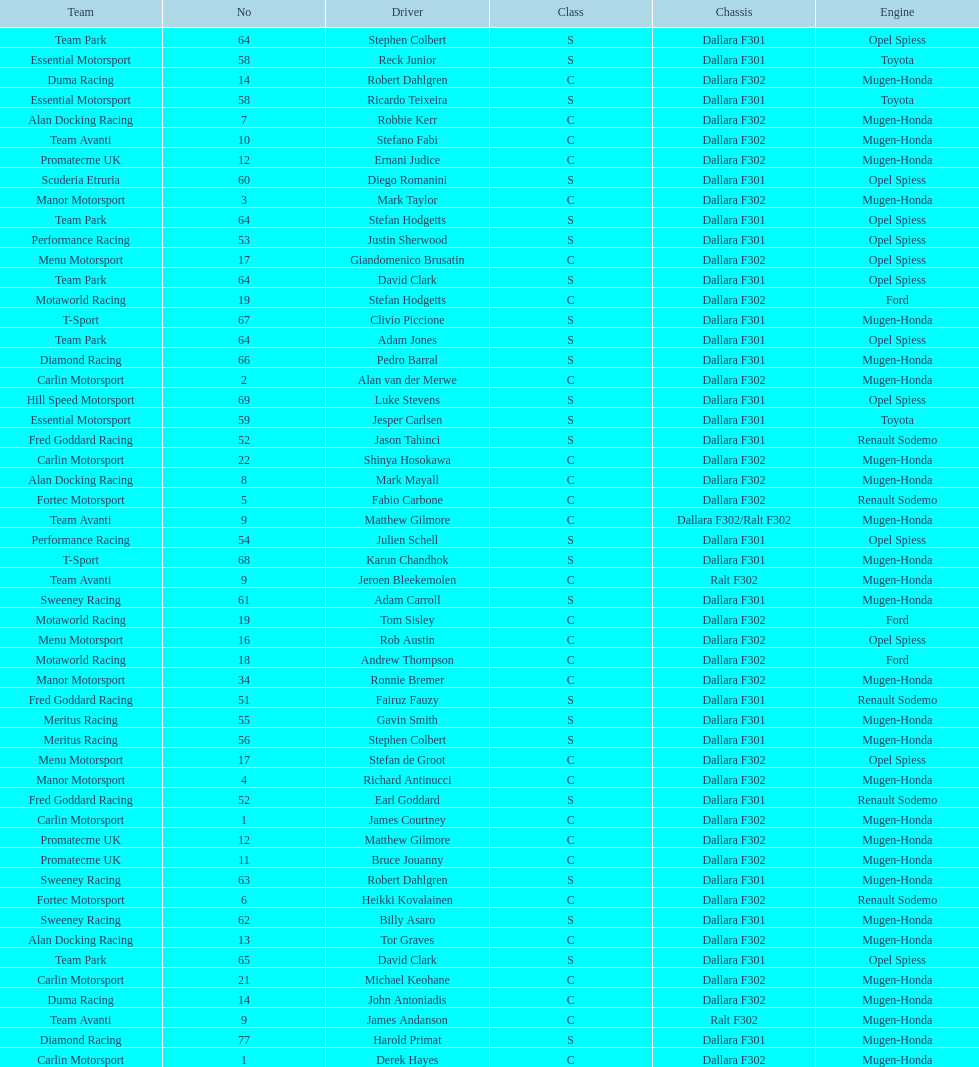What is the average number of teams that had a mugen-honda engine? 24. 